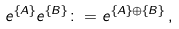Convert formula to latex. <formula><loc_0><loc_0><loc_500><loc_500>e ^ { \{ A \} } e ^ { \{ B \} } \colon = e ^ { \{ A \} \oplus \{ B \} } \, ,</formula> 